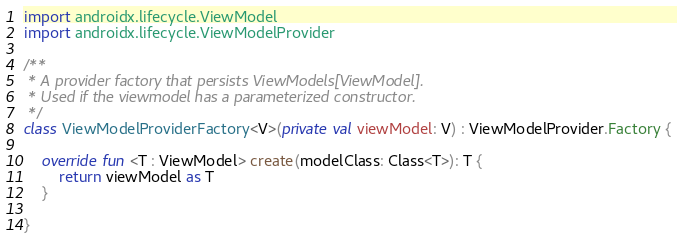<code> <loc_0><loc_0><loc_500><loc_500><_Kotlin_>
import androidx.lifecycle.ViewModel
import androidx.lifecycle.ViewModelProvider

/**
 * A provider factory that persists ViewModels[ViewModel].
 * Used if the viewmodel has a parameterized constructor.
 */
class ViewModelProviderFactory<V>(private val viewModel: V) : ViewModelProvider.Factory {

    override fun <T : ViewModel> create(modelClass: Class<T>): T {
        return viewModel as T
    }

}
</code> 